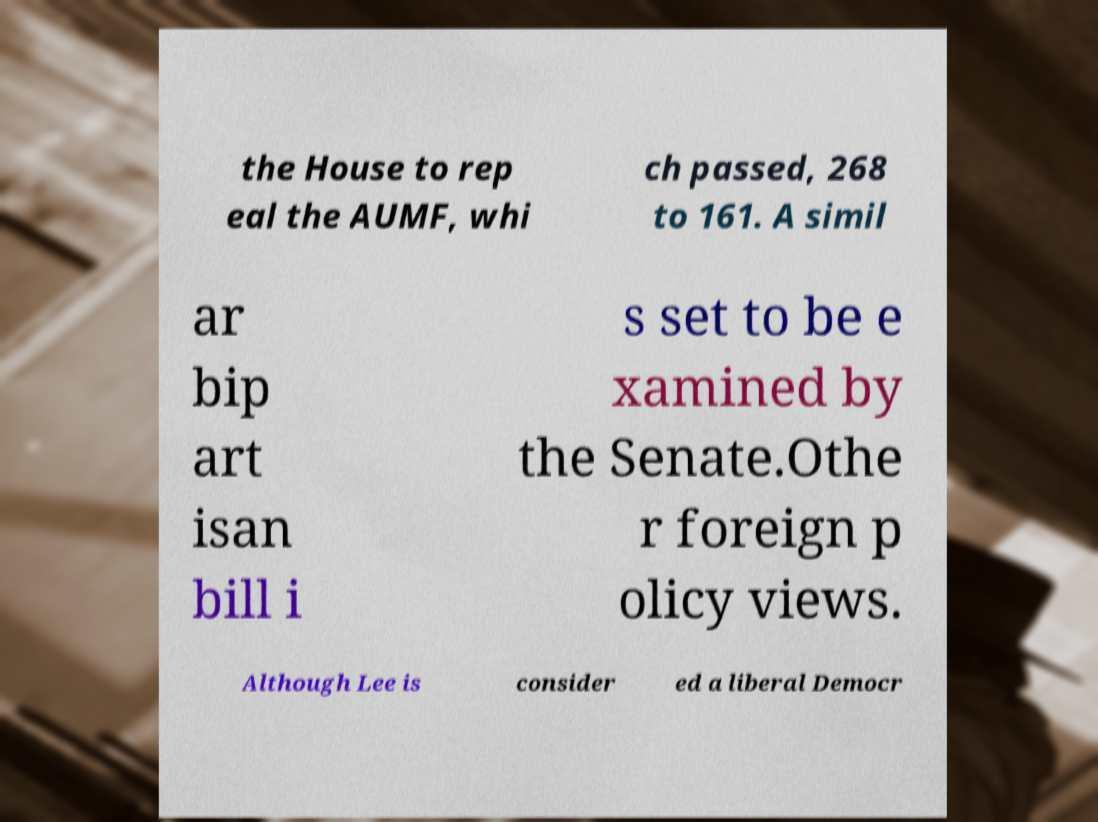Could you extract and type out the text from this image? the House to rep eal the AUMF, whi ch passed, 268 to 161. A simil ar bip art isan bill i s set to be e xamined by the Senate.Othe r foreign p olicy views. Although Lee is consider ed a liberal Democr 